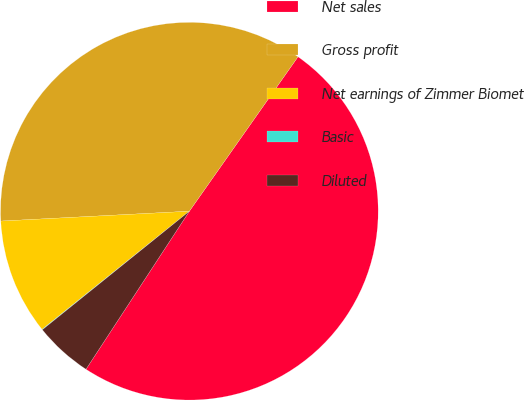<chart> <loc_0><loc_0><loc_500><loc_500><pie_chart><fcel>Net sales<fcel>Gross profit<fcel>Net earnings of Zimmer Biomet<fcel>Basic<fcel>Diluted<nl><fcel>49.46%<fcel>35.59%<fcel>9.93%<fcel>0.04%<fcel>4.98%<nl></chart> 